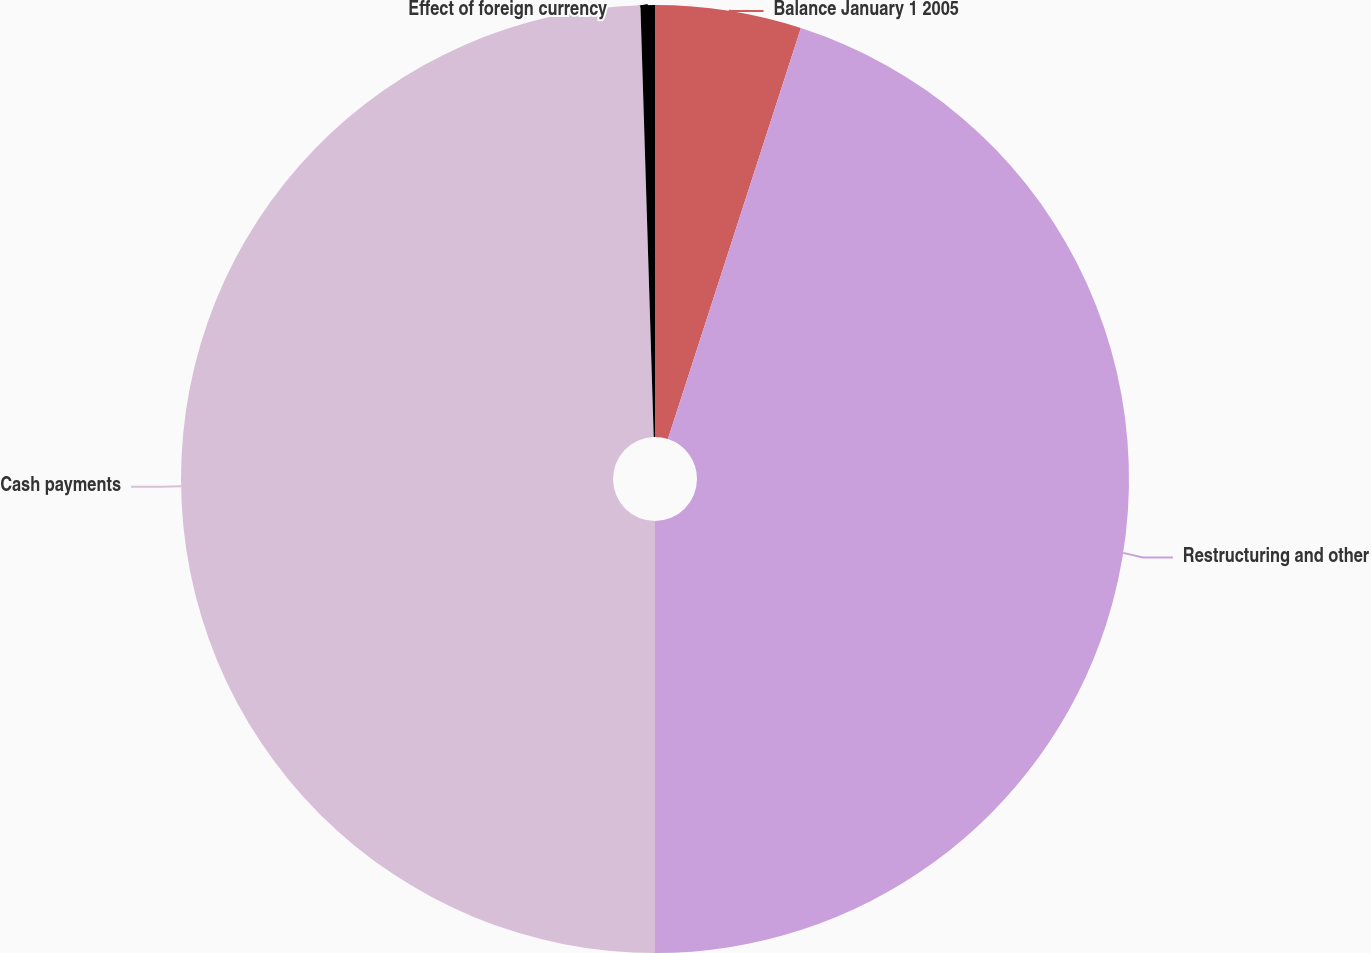Convert chart to OTSL. <chart><loc_0><loc_0><loc_500><loc_500><pie_chart><fcel>Balance January 1 2005<fcel>Restructuring and other<fcel>Cash payments<fcel>Effect of foreign currency<nl><fcel>4.98%<fcel>45.02%<fcel>49.51%<fcel>0.49%<nl></chart> 